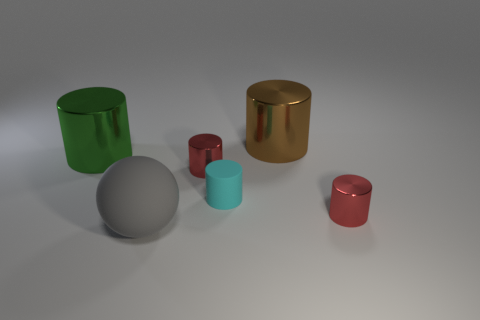Subtract 1 cylinders. How many cylinders are left? 4 Subtract all matte cylinders. How many cylinders are left? 4 Subtract all brown cylinders. How many cylinders are left? 4 Subtract all gray cylinders. Subtract all cyan cubes. How many cylinders are left? 5 Add 2 cyan balls. How many objects exist? 8 Subtract all cylinders. How many objects are left? 1 Subtract all red things. Subtract all big gray matte things. How many objects are left? 3 Add 2 large green cylinders. How many large green cylinders are left? 3 Add 6 purple cylinders. How many purple cylinders exist? 6 Subtract 0 yellow spheres. How many objects are left? 6 